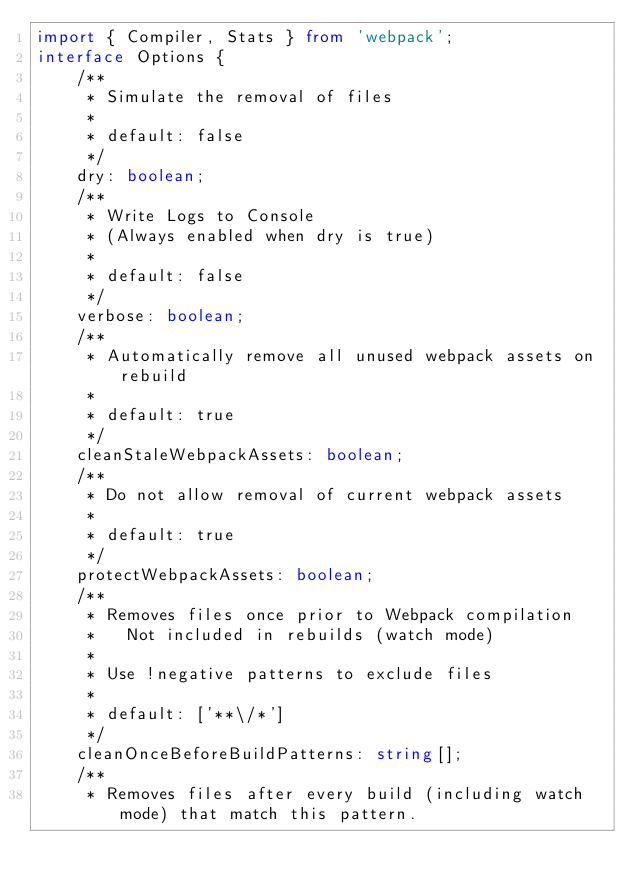<code> <loc_0><loc_0><loc_500><loc_500><_TypeScript_>import { Compiler, Stats } from 'webpack';
interface Options {
    /**
     * Simulate the removal of files
     *
     * default: false
     */
    dry: boolean;
    /**
     * Write Logs to Console
     * (Always enabled when dry is true)
     *
     * default: false
     */
    verbose: boolean;
    /**
     * Automatically remove all unused webpack assets on rebuild
     *
     * default: true
     */
    cleanStaleWebpackAssets: boolean;
    /**
     * Do not allow removal of current webpack assets
     *
     * default: true
     */
    protectWebpackAssets: boolean;
    /**
     * Removes files once prior to Webpack compilation
     *   Not included in rebuilds (watch mode)
     *
     * Use !negative patterns to exclude files
     *
     * default: ['**\/*']
     */
    cleanOnceBeforeBuildPatterns: string[];
    /**
     * Removes files after every build (including watch mode) that match this pattern.</code> 